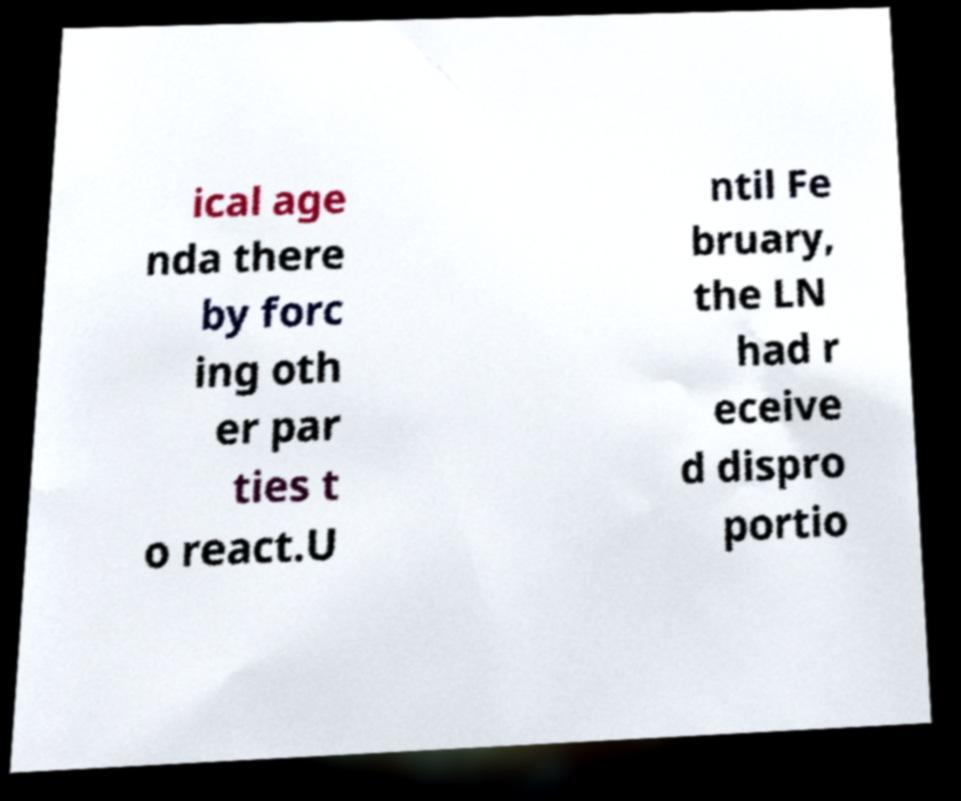Please read and relay the text visible in this image. What does it say? ical age nda there by forc ing oth er par ties t o react.U ntil Fe bruary, the LN had r eceive d dispro portio 